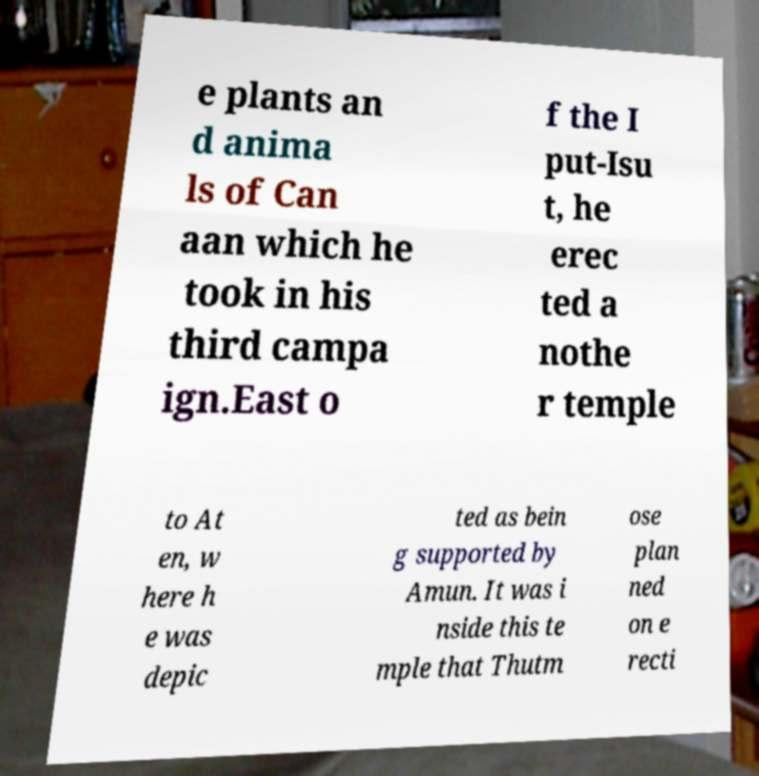Please identify and transcribe the text found in this image. e plants an d anima ls of Can aan which he took in his third campa ign.East o f the I put-Isu t, he erec ted a nothe r temple to At en, w here h e was depic ted as bein g supported by Amun. It was i nside this te mple that Thutm ose plan ned on e recti 